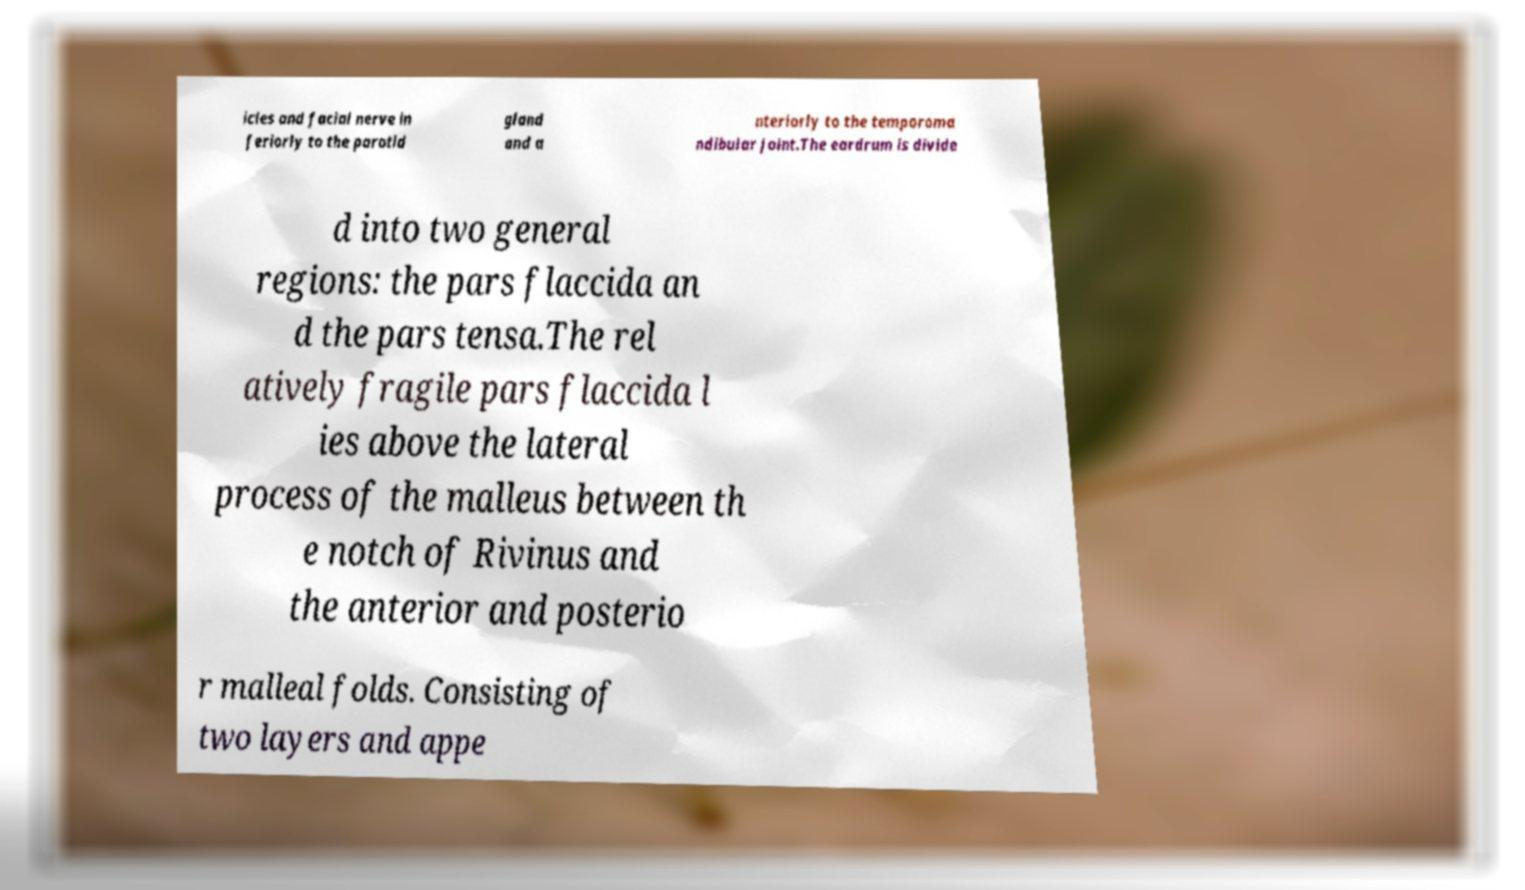For documentation purposes, I need the text within this image transcribed. Could you provide that? icles and facial nerve in feriorly to the parotid gland and a nteriorly to the temporoma ndibular joint.The eardrum is divide d into two general regions: the pars flaccida an d the pars tensa.The rel atively fragile pars flaccida l ies above the lateral process of the malleus between th e notch of Rivinus and the anterior and posterio r malleal folds. Consisting of two layers and appe 